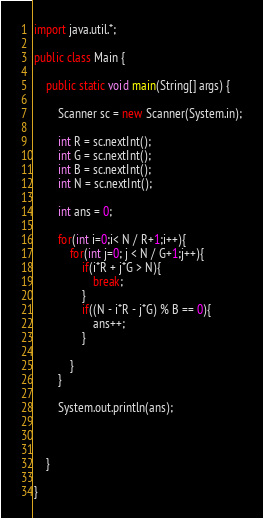<code> <loc_0><loc_0><loc_500><loc_500><_Java_>import java.util.*;

public class Main {

    public static void main(String[] args) {

        Scanner sc = new Scanner(System.in);

        int R = sc.nextInt();
        int G = sc.nextInt();
        int B = sc.nextInt();
        int N = sc.nextInt();

        int ans = 0;

        for(int i=0;i< N / R+1;i++){
            for(int j=0; j < N / G+1;j++){
                if(i*R + j*G > N){
                    break;
                }
                if((N - i*R - j*G) % B == 0){
                    ans++;
                }

            }
        }

        System.out.println(ans);



    }

}
</code> 